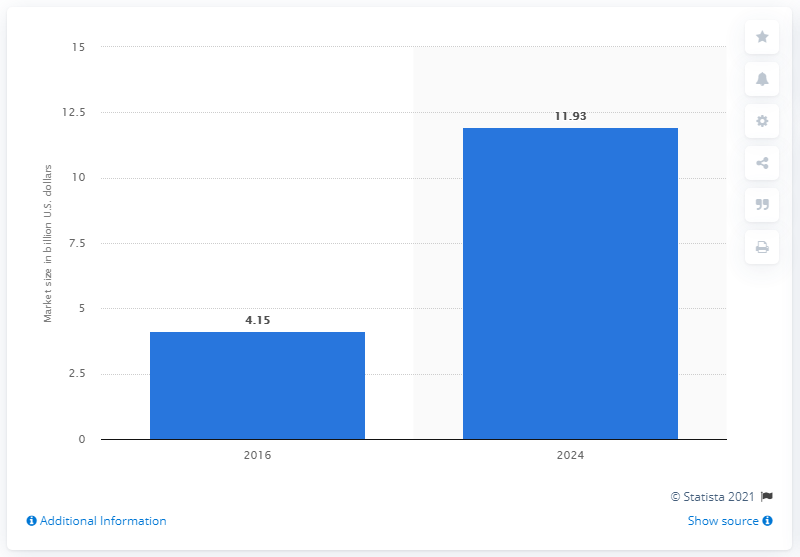Mention a couple of crucial points in this snapshot. The forecast for the next generation sequencing market is for the year 2024. The estimated value of the global next generation sequencing market is expected to be approximately 11.93... by 2024. 